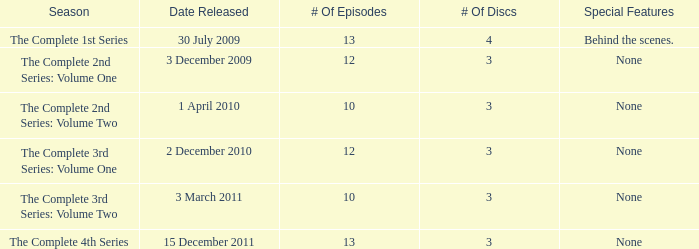Can you parse all the data within this table? {'header': ['Season', 'Date Released', '# Of Episodes', '# Of Discs', 'Special Features'], 'rows': [['The Complete 1st Series', '30 July 2009', '13', '4', 'Behind the scenes.'], ['The Complete 2nd Series: Volume One', '3 December 2009', '12', '3', 'None'], ['The Complete 2nd Series: Volume Two', '1 April 2010', '10', '3', 'None'], ['The Complete 3rd Series: Volume One', '2 December 2010', '12', '3', 'None'], ['The Complete 3rd Series: Volume Two', '3 March 2011', '10', '3', 'None'], ['The Complete 4th Series', '15 December 2011', '13', '3', 'None']]} On how many dates was the complete 4th series released? 1.0. 